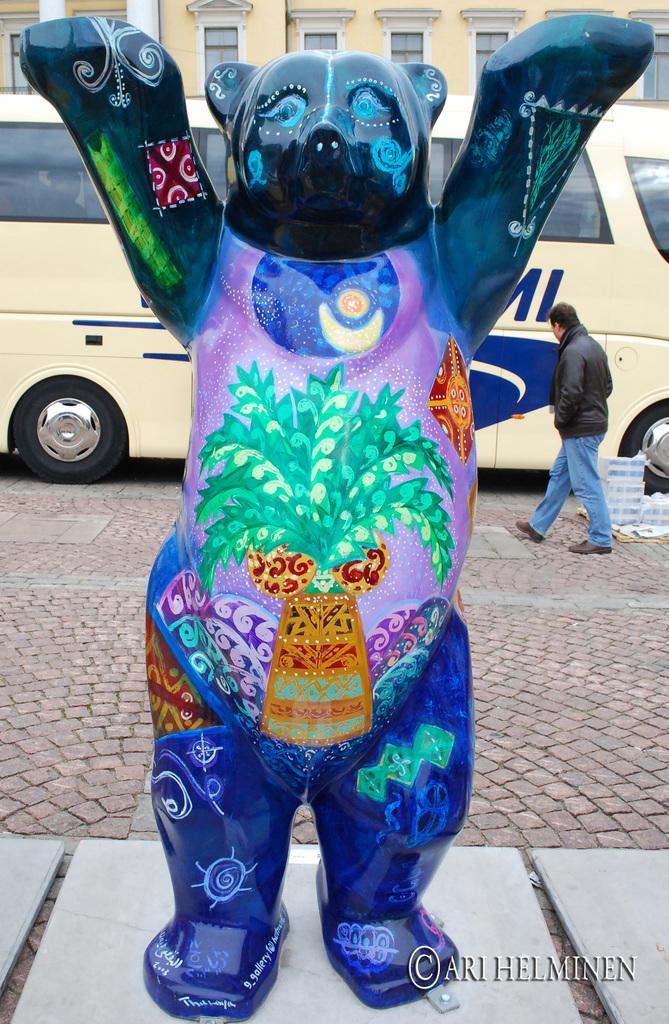Describe this image in one or two sentences. In this image, we can see a person, a vehicle, a toy and the ground with some objects. We can also see the wall with some windows and white colored objects. We can also see some text on the bottom right corner. 